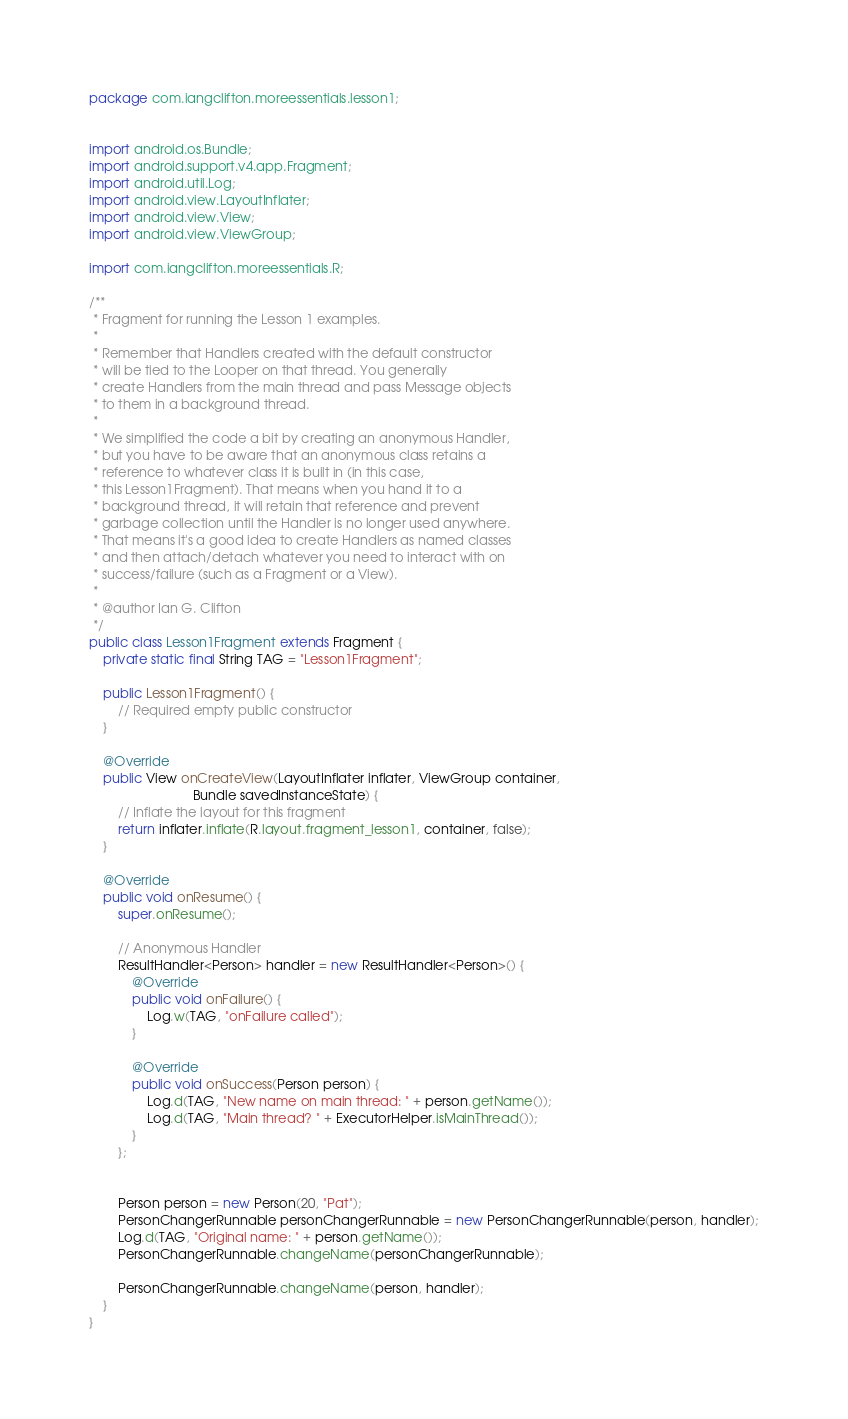<code> <loc_0><loc_0><loc_500><loc_500><_Java_>package com.iangclifton.moreessentials.lesson1;


import android.os.Bundle;
import android.support.v4.app.Fragment;
import android.util.Log;
import android.view.LayoutInflater;
import android.view.View;
import android.view.ViewGroup;

import com.iangclifton.moreessentials.R;

/**
 * Fragment for running the Lesson 1 examples.
 *
 * Remember that Handlers created with the default constructor
 * will be tied to the Looper on that thread. You generally
 * create Handlers from the main thread and pass Message objects
 * to them in a background thread.
 *
 * We simplified the code a bit by creating an anonymous Handler,
 * but you have to be aware that an anonymous class retains a
 * reference to whatever class it is built in (in this case,
 * this Lesson1Fragment). That means when you hand it to a
 * background thread, it will retain that reference and prevent
 * garbage collection until the Handler is no longer used anywhere.
 * That means it's a good idea to create Handlers as named classes
 * and then attach/detach whatever you need to interact with on
 * success/failure (such as a Fragment or a View).
 *
 * @author Ian G. Clifton
 */
public class Lesson1Fragment extends Fragment {
    private static final String TAG = "Lesson1Fragment";

    public Lesson1Fragment() {
        // Required empty public constructor
    }

    @Override
    public View onCreateView(LayoutInflater inflater, ViewGroup container,
                             Bundle savedInstanceState) {
        // Inflate the layout for this fragment
        return inflater.inflate(R.layout.fragment_lesson1, container, false);
    }

    @Override
    public void onResume() {
        super.onResume();

        // Anonymous Handler
        ResultHandler<Person> handler = new ResultHandler<Person>() {
            @Override
            public void onFailure() {
                Log.w(TAG, "onFailure called");
            }

            @Override
            public void onSuccess(Person person) {
                Log.d(TAG, "New name on main thread: " + person.getName());
                Log.d(TAG, "Main thread? " + ExecutorHelper.isMainThread());
            }
        };


        Person person = new Person(20, "Pat");
        PersonChangerRunnable personChangerRunnable = new PersonChangerRunnable(person, handler);
        Log.d(TAG, "Original name: " + person.getName());
        PersonChangerRunnable.changeName(personChangerRunnable);

        PersonChangerRunnable.changeName(person, handler);
    }
}
</code> 